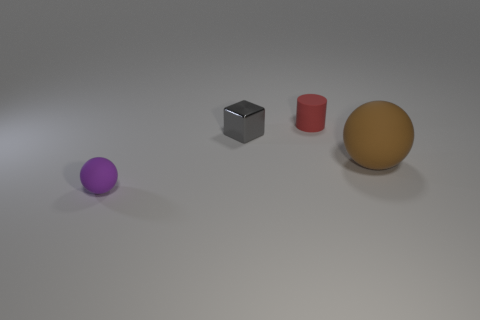Add 1 tiny green shiny spheres. How many objects exist? 5 Subtract 0 gray cylinders. How many objects are left? 4 Subtract all cylinders. How many objects are left? 3 Subtract all red balls. Subtract all blue cylinders. How many balls are left? 2 Subtract all big cyan rubber cylinders. Subtract all matte balls. How many objects are left? 2 Add 4 metal blocks. How many metal blocks are left? 5 Add 3 tiny gray rubber cylinders. How many tiny gray rubber cylinders exist? 3 